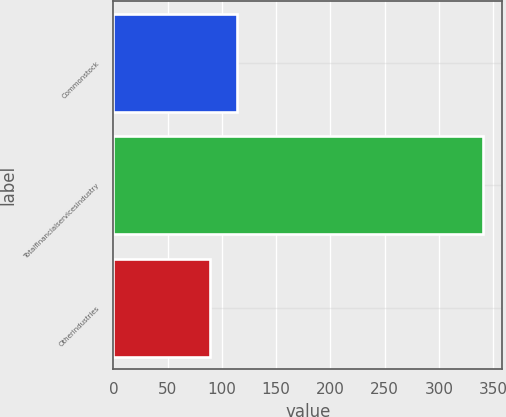Convert chart. <chart><loc_0><loc_0><loc_500><loc_500><bar_chart><fcel>Commonstock<fcel>Totalfinancialservicesindustry<fcel>Otherindustries<nl><fcel>114.2<fcel>341<fcel>89<nl></chart> 